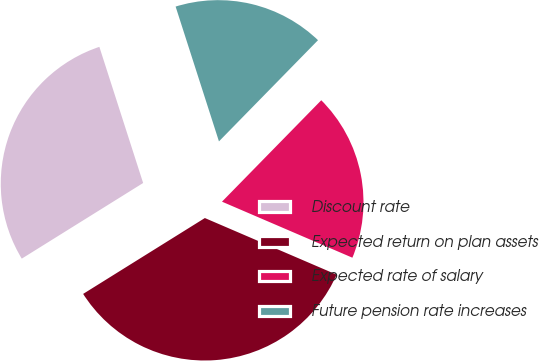<chart> <loc_0><loc_0><loc_500><loc_500><pie_chart><fcel>Discount rate<fcel>Expected return on plan assets<fcel>Expected rate of salary<fcel>Future pension rate increases<nl><fcel>28.92%<fcel>34.67%<fcel>19.13%<fcel>17.28%<nl></chart> 